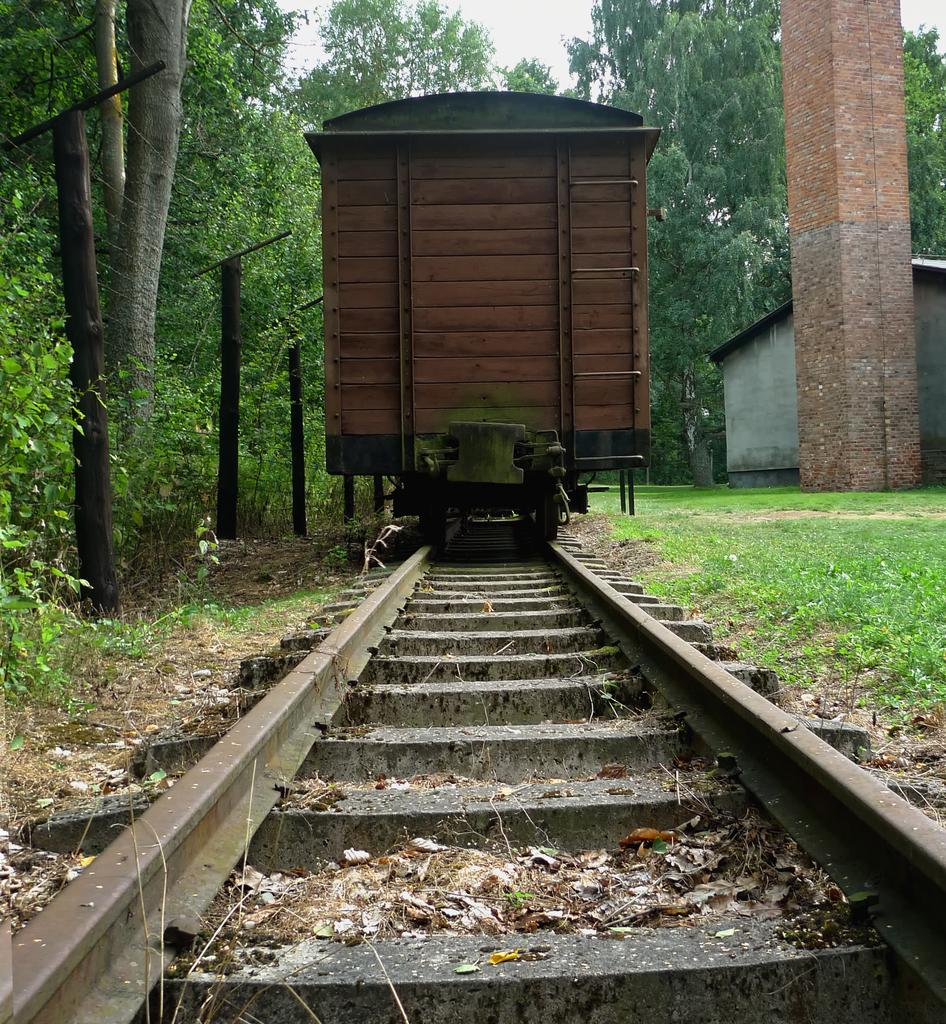What is in the foreground of the image? There is a railway track in the foreground of the image. What is on the railway track? There is a train on the railway track. What type of vegetation can be seen around the train? Grass is visible around the train. Can you describe any structures in the image? There is a pillar and a house in the image. What else can be seen in the image? Trees are present in the image. What type of zephyr can be seen blowing through the pages of the picture in the image? There is no zephyr or picture present in the image; it features a railway track, a train, grass, a pillar, a house, and trees. 